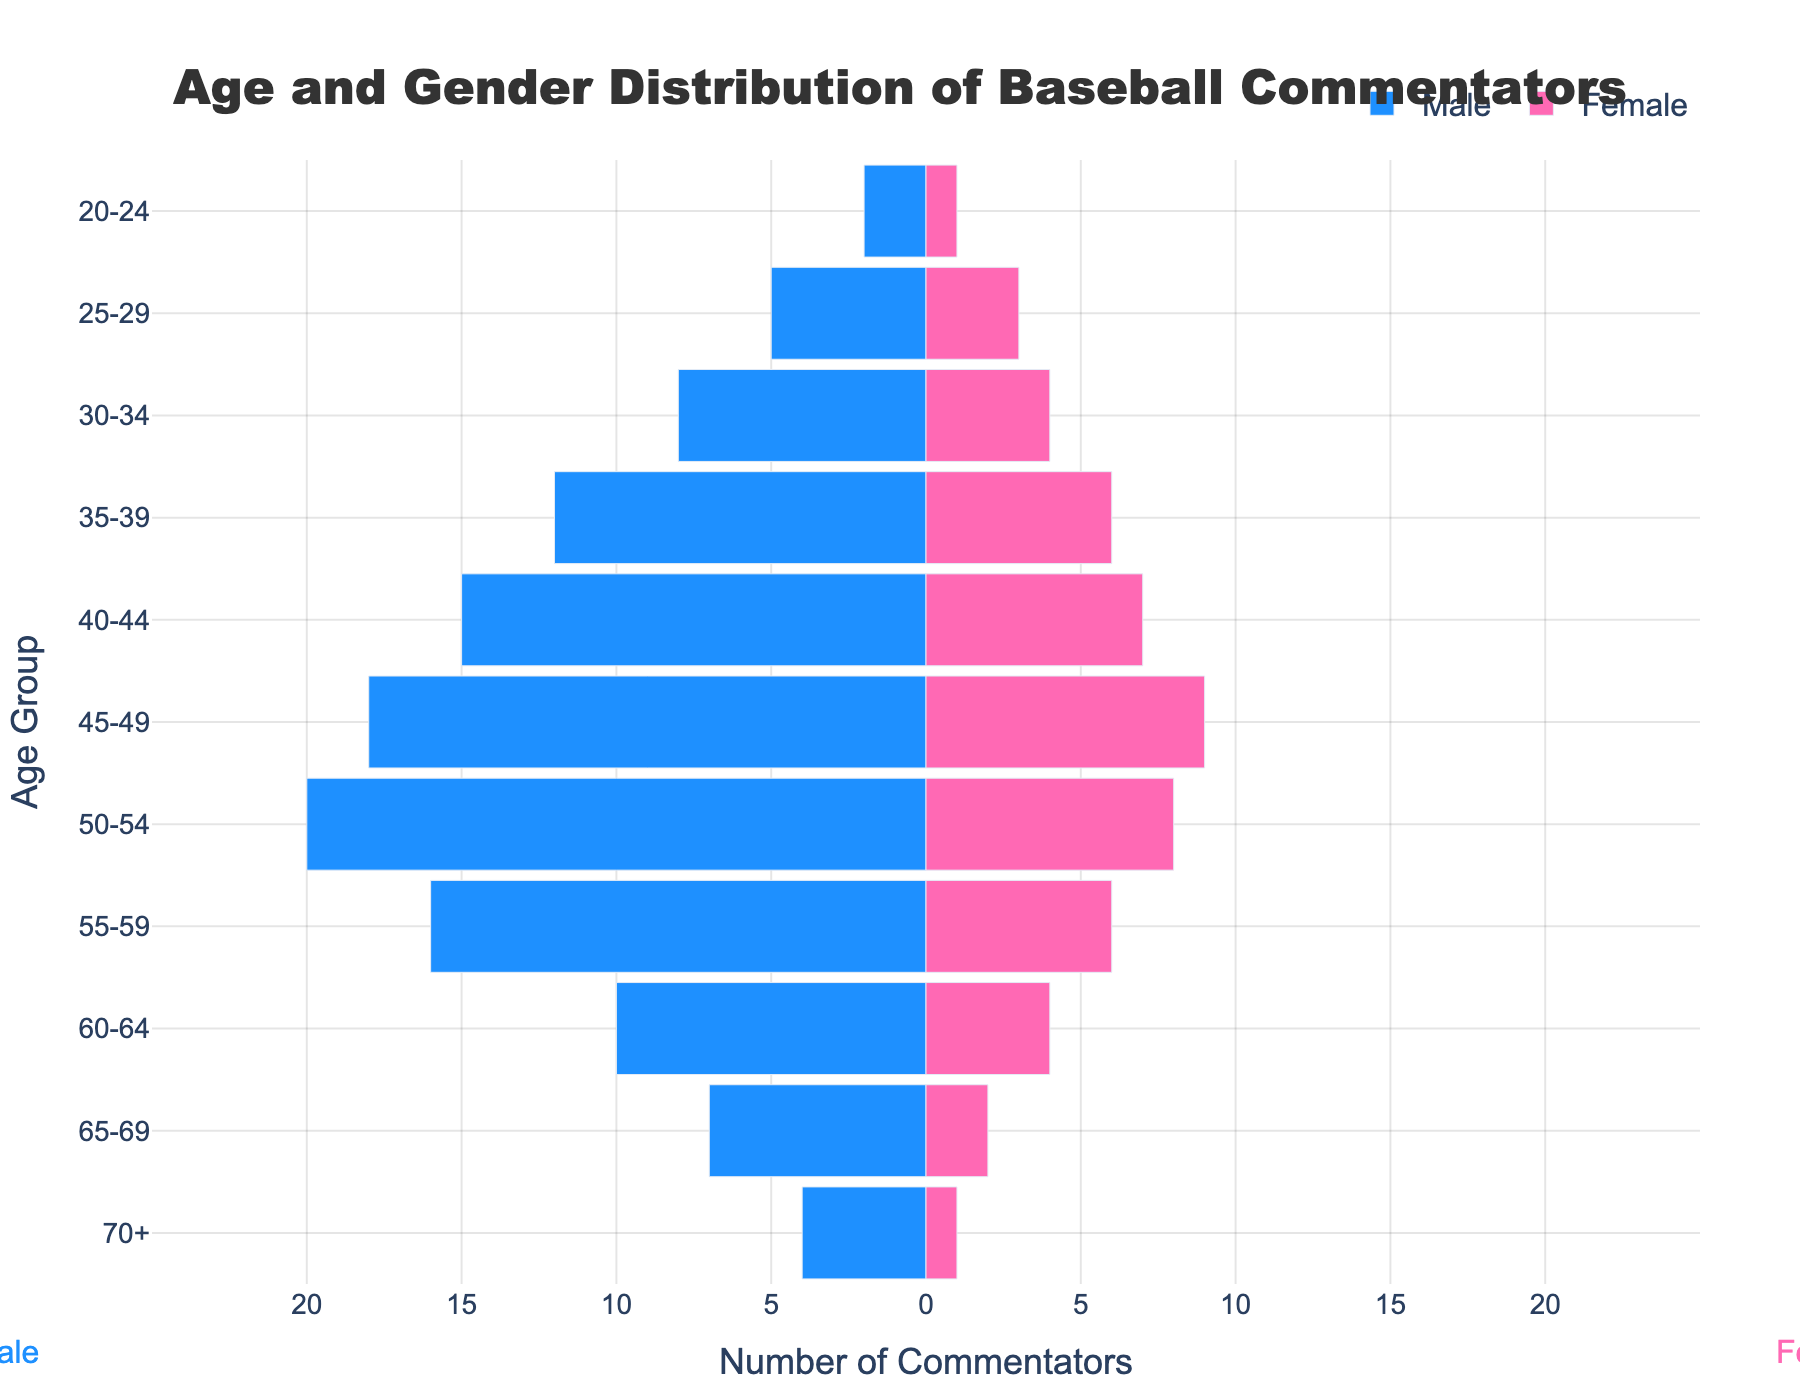What's the title of the figure? The title is positioned at the top center of the figure. It reads "Age and Gender Distribution of Baseball Commentators".
Answer: Age and Gender Distribution of Baseball Commentators What are the colors used to represent males and females in the bars? The left-side bars representing males are colored blue, and the right-side bars representing females are colored pink.
Answer: Blue and Pink In the age group 50-54, how many males and females are there? In the 50-54 age group, there are two bars shown: -20 for males and 8 for females.
Answer: Males: 20, Females: 8 Which age group has the highest number of male commentators? The group 50-54 has the -20 value for males, the highest negative value, indicating the largest group of male commentators.
Answer: 50-54 How many more males are there than females in the 40-44 age group? For the age group 40-44, there are 15 males and 7 females. The difference is 15 - 7.
Answer: 8 What is the most populous age group for female commentators? By looking at the heights of the pink bars, the highest number of females, 9, is in the age group 45-49.
Answer: 45-49 What is the total number of female commentators aged 55 and older? Sum the female values for age groups 55-59, 60-64, 65-69, and 70+: 6 + 4 + 2 + 1.
Answer: 13 Is there an age group where the number of males is the same as the number of females? None of the age groups show equal numbers for both genders based on the lengths of bars.
Answer: No What is the age group with the lowest total number of commentators (males + females)? The 20-24 group has 2 males and 1 female, totaling 3, which is the lowest combined number.
Answer: 20-24 